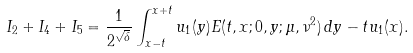<formula> <loc_0><loc_0><loc_500><loc_500>I _ { 2 } + I _ { 4 } + I _ { 5 } = \frac { 1 } { 2 ^ { \sqrt { \delta } } } \int _ { x - t } ^ { x + t } u _ { 1 } ( y ) E ( t , x ; 0 , y ; \mu , \nu ^ { 2 } ) \, d y - t u _ { 1 } ( x ) .</formula> 